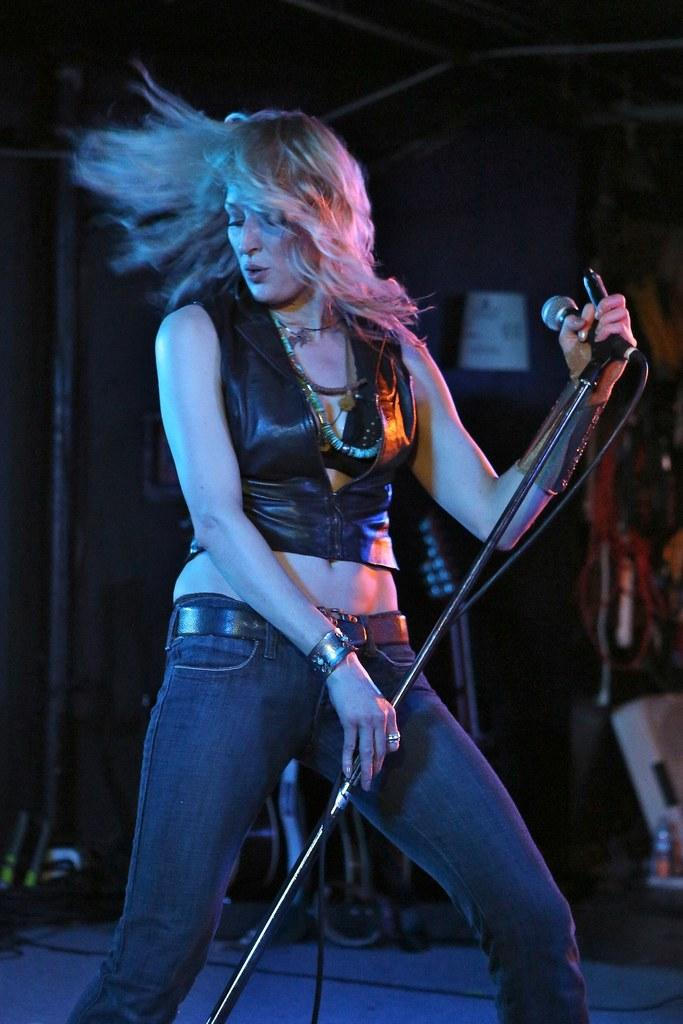Who is the main subject in the image? There is a lady in the center of the image. What is the lady holding in the image? The lady is holding a mic. What can be seen in the background of the image? There is a wall in the background of the image. What type of plane can be seen flying in the image? There is no plane visible in the image; it only features a lady holding a mic with a wall in the background. 